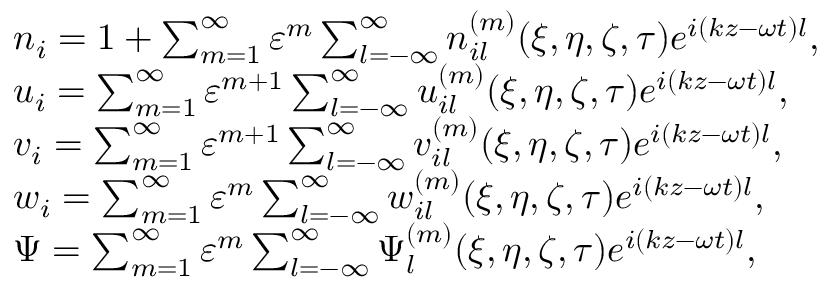Convert formula to latex. <formula><loc_0><loc_0><loc_500><loc_500>\begin{array} { r l } & { n _ { i } = 1 + \sum _ { m = 1 } ^ { \infty } \varepsilon ^ { m } \sum _ { l = - \infty } ^ { \infty } n _ { i l } ^ { ( m ) } ( \xi , \eta , \zeta , \tau ) e ^ { i ( k z - \omega t ) l } , } \\ & { u _ { i } = \sum _ { m = 1 } ^ { \infty } \varepsilon ^ { m + 1 } \sum _ { l = - \infty } ^ { \infty } u _ { i l } ^ { ( m ) } ( \xi , \eta , \zeta , \tau ) e ^ { i ( k z - \omega t ) l } , } \\ & { v _ { i } = \sum _ { m = 1 } ^ { \infty } \varepsilon ^ { m + 1 } \sum _ { l = - \infty } ^ { \infty } v _ { i l } ^ { ( m ) } ( \xi , \eta , \zeta , \tau ) e ^ { i ( k z - \omega t ) l } , } \\ & { w _ { i } = \sum _ { m = 1 } ^ { \infty } \varepsilon ^ { m } \sum _ { l = - \infty } ^ { \infty } w _ { i l } ^ { ( m ) } ( \xi , \eta , \zeta , \tau ) e ^ { i ( k z - \omega t ) l } , } \\ & { \Psi = \sum _ { m = 1 } ^ { \infty } \varepsilon ^ { m } \sum _ { l = - \infty } ^ { \infty } \Psi _ { l } ^ { ( m ) } ( \xi , \eta , \zeta , \tau ) e ^ { i ( k z - \omega t ) l } , } \end{array}</formula> 